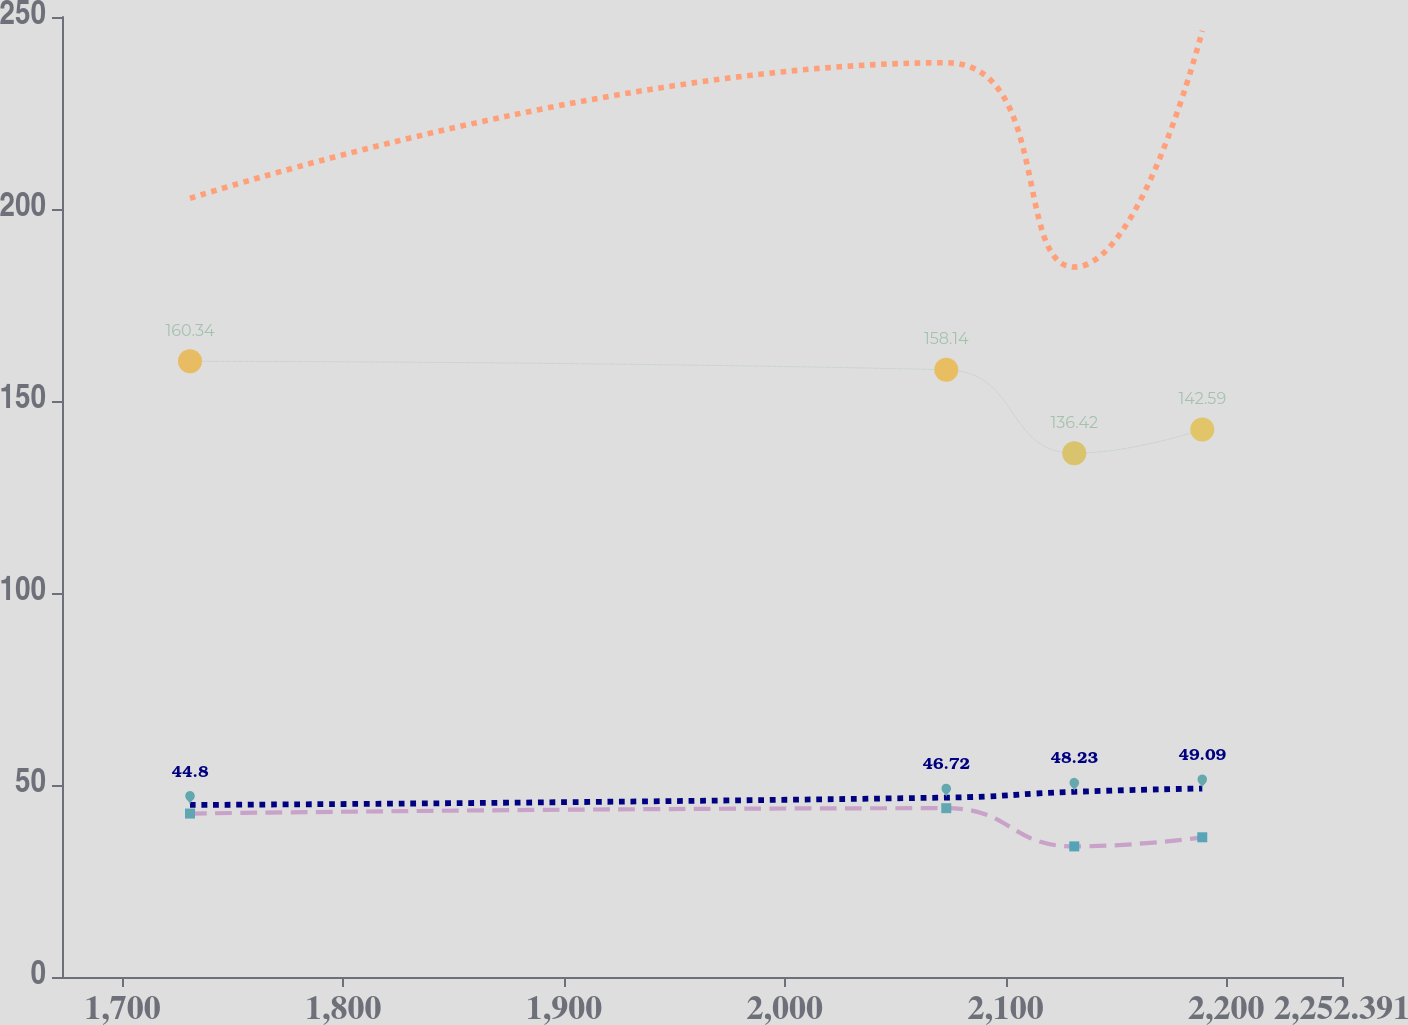Convert chart to OTSL. <chart><loc_0><loc_0><loc_500><loc_500><line_chart><ecel><fcel>Other Retiree Benefit Plans<fcel>International<fcel>United States<fcel>Total<nl><fcel>1730.58<fcel>160.34<fcel>42.56<fcel>44.8<fcel>202.78<nl><fcel>2073.14<fcel>158.14<fcel>43.96<fcel>46.72<fcel>238.09<nl><fcel>2131.12<fcel>136.42<fcel>34.01<fcel>48.23<fcel>184.88<nl><fcel>2189.1<fcel>142.59<fcel>36.38<fcel>49.09<fcel>246.43<nl><fcel>2310.37<fcel>138.62<fcel>31.16<fcel>53.41<fcel>268.26<nl></chart> 